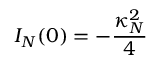Convert formula to latex. <formula><loc_0><loc_0><loc_500><loc_500>I _ { N } ( 0 ) = - { \frac { \kappa _ { N } ^ { 2 } } { 4 } }</formula> 